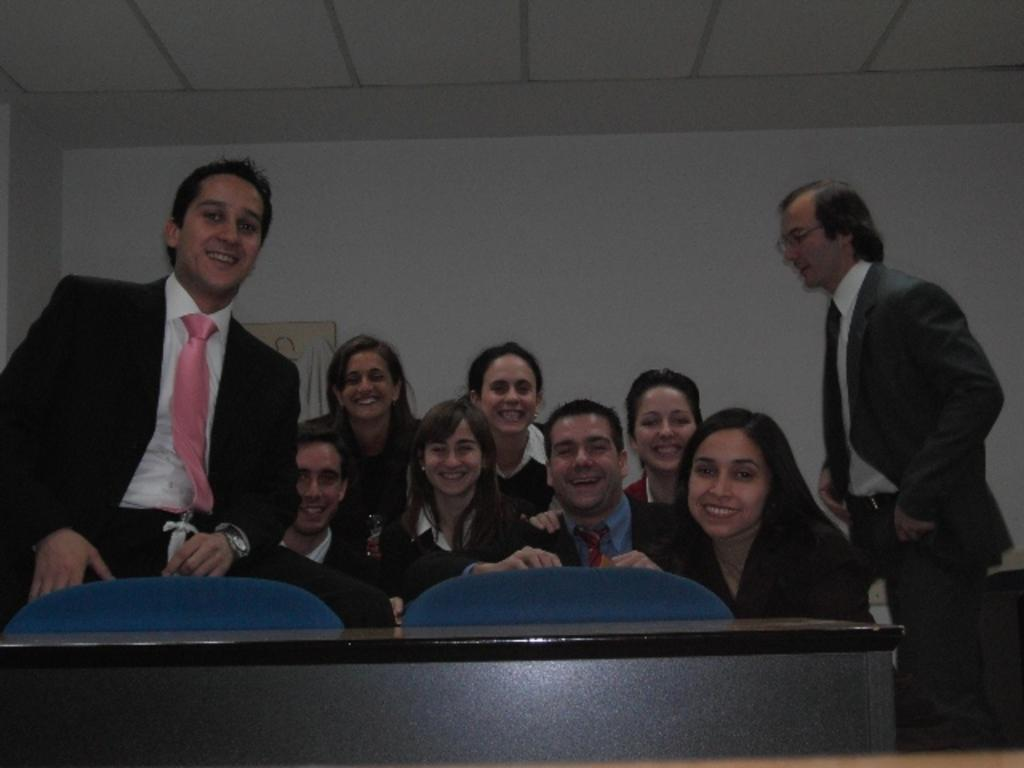Who is present in the image? There are people in the image. What is the facial expression of the people in the image? The people are smiling. What type of furniture is visible in the image? There are chairs and a table in the image. What can be seen on the wall in the background of the image? There is a board on the wall in the background of the image. What story is the brother telling in the image? There is no brother present in the image, nor is there any indication of a story being told. 